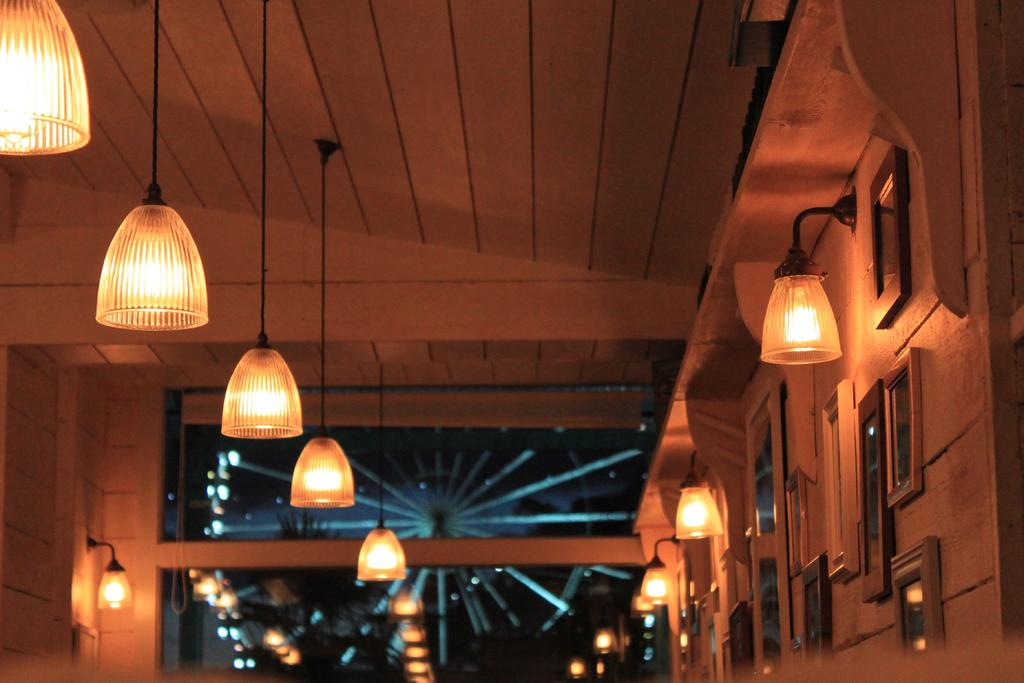What is hanging on the wall in the image? There are frames on the wall in the image. What can be seen providing illumination in the image? There are lights in the image. What type of object can be seen in the background of the image? There is a joint wheel visible in the background of the image. Reasoning: Let' Let's think step by step in order to produce the conversation. We start by identifying the main subjects and objects in the image based on the provided facts. We then formulate questions that focus on the location and characteristics of these subjects and objects, ensuring that each question can be answered definitively with the information given. We avoid yes/no questions and ensure that the language is simple and clear. Absurd Question/Answer: What type of sail can be seen in the image? There is no sail present in the image. How can the cushion be used in the image? There is no cushion present in the image. What type of sail can be seen in the image? There is no sail present in the image. How can the cushion be used in the image? There is no cushion present in the image. 